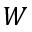<formula> <loc_0><loc_0><loc_500><loc_500>W</formula> 